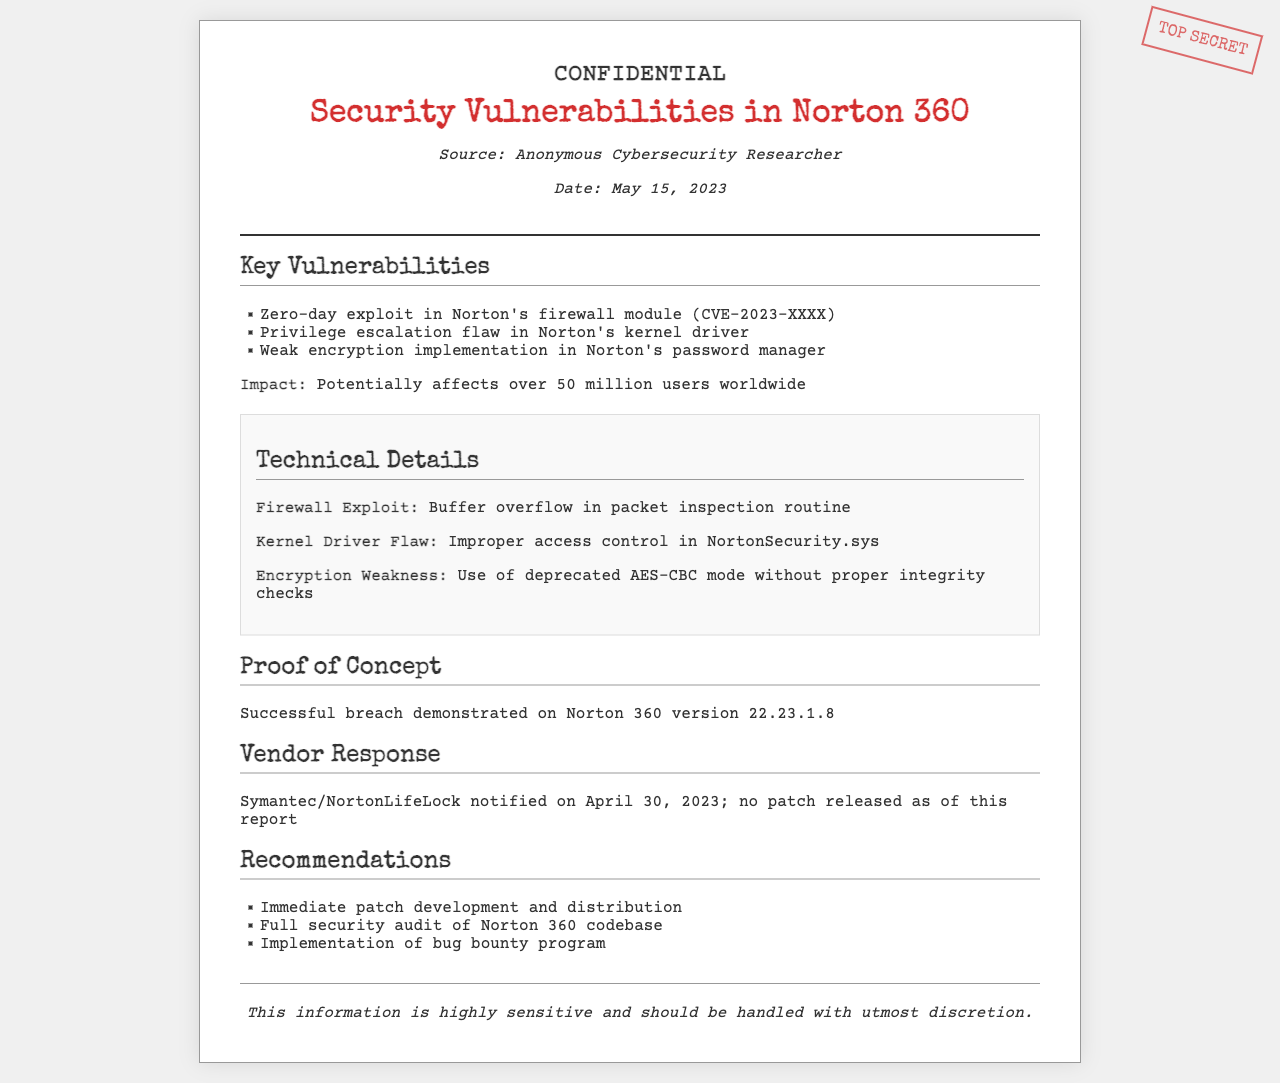what is the title of the report? The title of the report is found at the top of the document, clearly stated as "Security Vulnerabilities in Norton 360."
Answer: Security Vulnerabilities in Norton 360 who is the source of the report? The source of the report is mentioned in the meta information section, which identifies the source as "Anonymous Cybersecurity Researcher."
Answer: Anonymous Cybersecurity Researcher what is the date of the report? The date of the report is provided in the meta information section as "May 15, 2023."
Answer: May 15, 2023 what is the first key vulnerability listed? The first key vulnerability is the first item in the list under "Key Vulnerabilities," described as a "zero-day exploit in Norton's firewall module."
Answer: Zero-day exploit in Norton's firewall module how many users could potentially be affected by these vulnerabilities? The document states the impact of the vulnerabilities potentially affects "over 50 million users worldwide."
Answer: Over 50 million users what is the proof of concept mentioned in the report? The proof of concept is outlined under its own section, indicating a successful breach demonstrated on a specific version of Norton 360.
Answer: Norton 360 version 22.23.1.8 when was the vendor notified about the vulnerabilities? The document specifies the notification date to the vendor as "April 30, 2023."
Answer: April 30, 2023 what is one recommendation given in the report? The recommendations are listed, with the first one being "Immediate patch development and distribution."
Answer: Immediate patch development and distribution what are the technical details about the firewall exploit? The technical details are given in a subsection, specifying the exploit involves a "buffer overflow in packet inspection routine."
Answer: Buffer overflow in packet inspection routine 